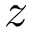<formula> <loc_0><loc_0><loc_500><loc_500>z</formula> 